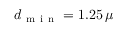<formula> <loc_0><loc_0><loc_500><loc_500>d _ { m i n } = 1 . 2 5 \, \mu</formula> 